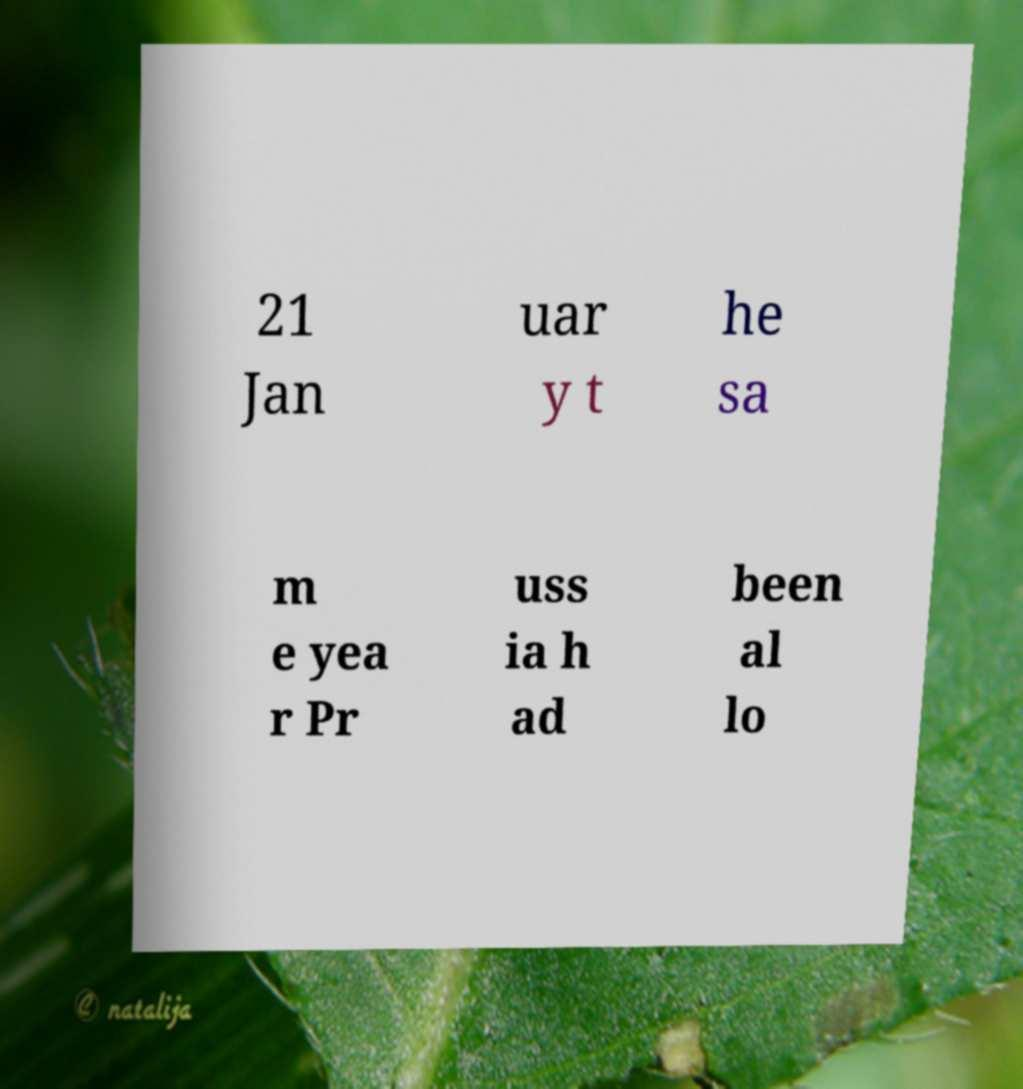What messages or text are displayed in this image? I need them in a readable, typed format. 21 Jan uar y t he sa m e yea r Pr uss ia h ad been al lo 